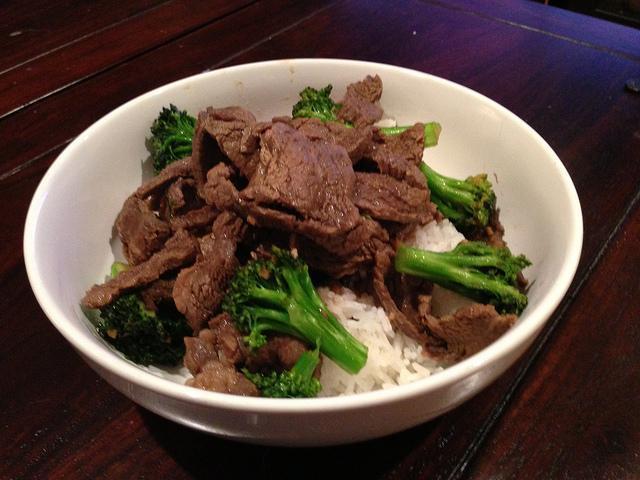How many broccolis are visible?
Give a very brief answer. 3. 